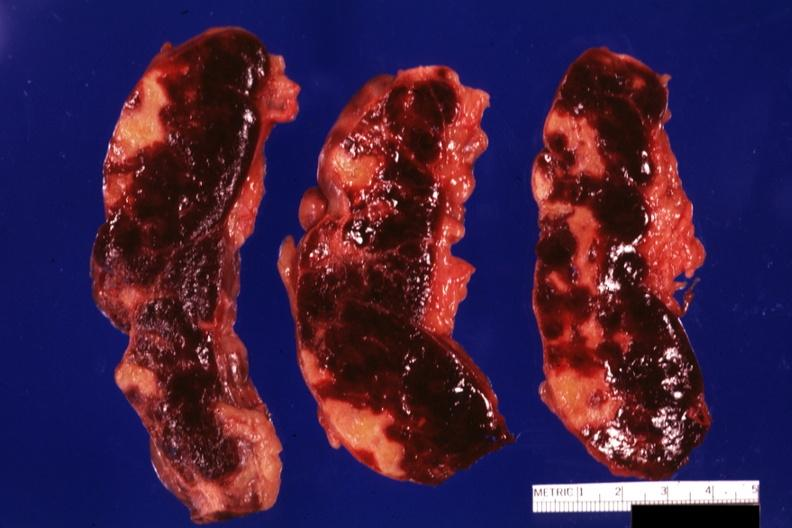does this image show three cut sections many lesions several days of age?
Answer the question using a single word or phrase. Yes 